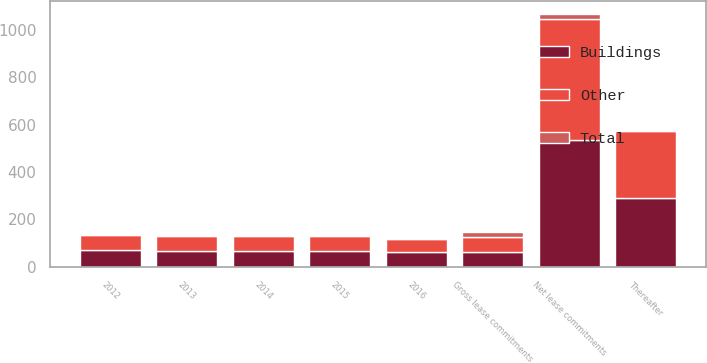Convert chart to OTSL. <chart><loc_0><loc_0><loc_500><loc_500><stacked_bar_chart><ecel><fcel>2012<fcel>2013<fcel>2014<fcel>2015<fcel>2016<fcel>Thereafter<fcel>Gross lease commitments<fcel>Net lease commitments<nl><fcel>Buildings<fcel>69.4<fcel>67<fcel>66.1<fcel>66.9<fcel>60.1<fcel>288.5<fcel>62.3<fcel>533.8<nl><fcel>Other<fcel>65<fcel>62.7<fcel>61.9<fcel>63.5<fcel>58.3<fcel>285.8<fcel>62.3<fcel>513<nl><fcel>Total<fcel>4.4<fcel>4.3<fcel>4.2<fcel>3.4<fcel>1.8<fcel>2.7<fcel>20.8<fcel>20.8<nl></chart> 